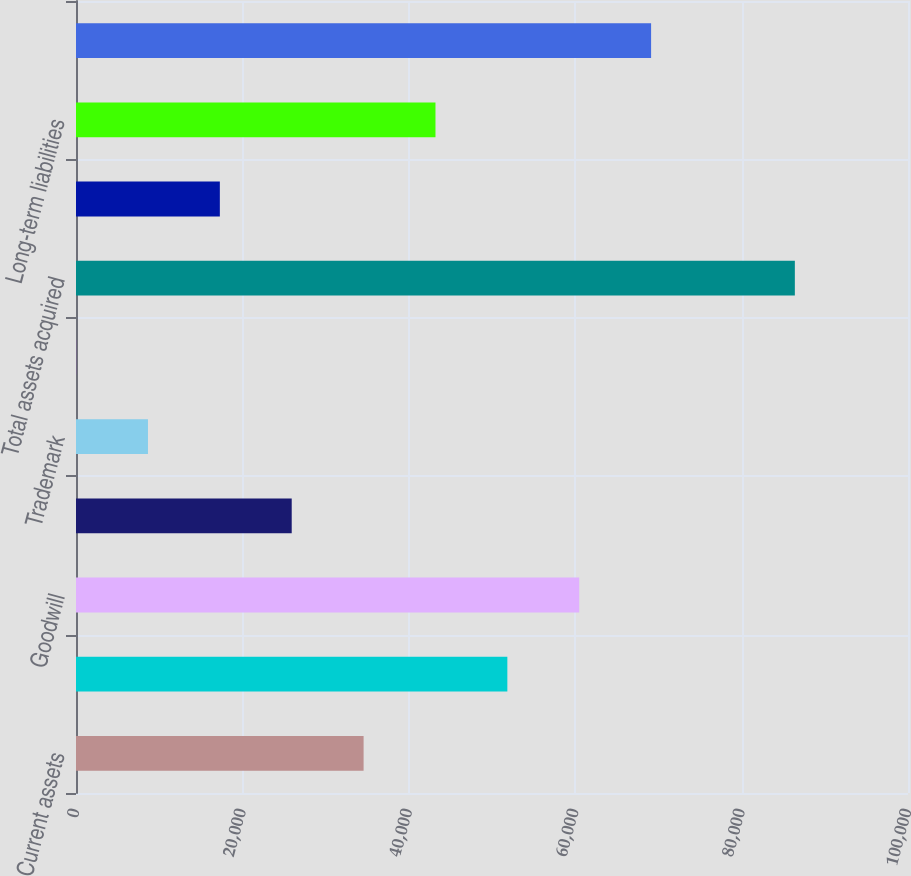<chart> <loc_0><loc_0><loc_500><loc_500><bar_chart><fcel>Current assets<fcel>Property and equipment net<fcel>Goodwill<fcel>Customer-related intangible<fcel>Trademark<fcel>Other long-term assets<fcel>Total assets acquired<fcel>Current liabilities<fcel>Long-term liabilities<fcel>Net assets acquired<nl><fcel>34566.6<fcel>51844.4<fcel>60483.3<fcel>25927.7<fcel>8649.9<fcel>11<fcel>86400<fcel>17288.8<fcel>43205.5<fcel>69122.2<nl></chart> 